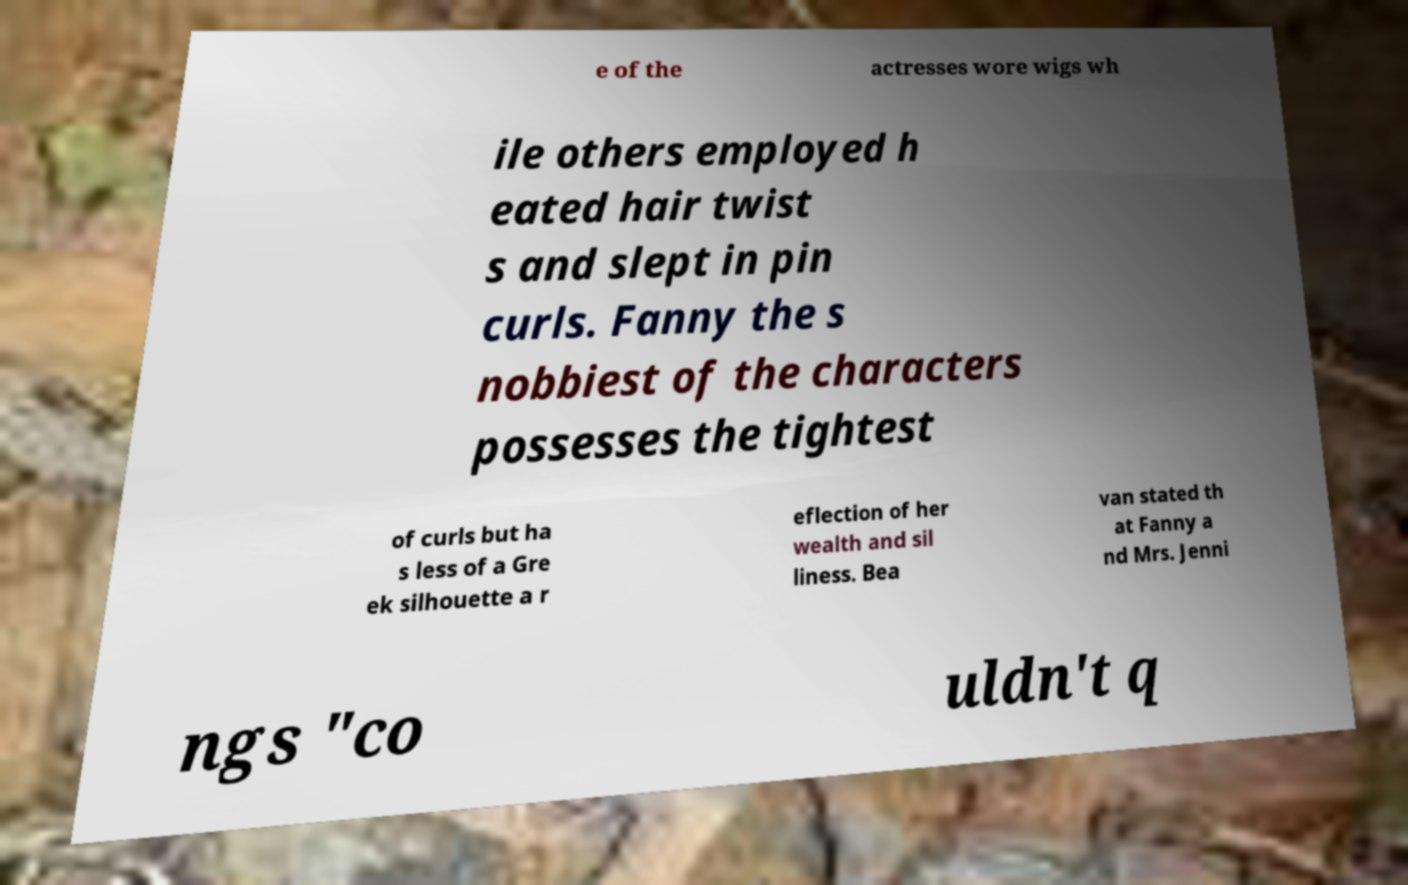I need the written content from this picture converted into text. Can you do that? e of the actresses wore wigs wh ile others employed h eated hair twist s and slept in pin curls. Fanny the s nobbiest of the characters possesses the tightest of curls but ha s less of a Gre ek silhouette a r eflection of her wealth and sil liness. Bea van stated th at Fanny a nd Mrs. Jenni ngs "co uldn't q 